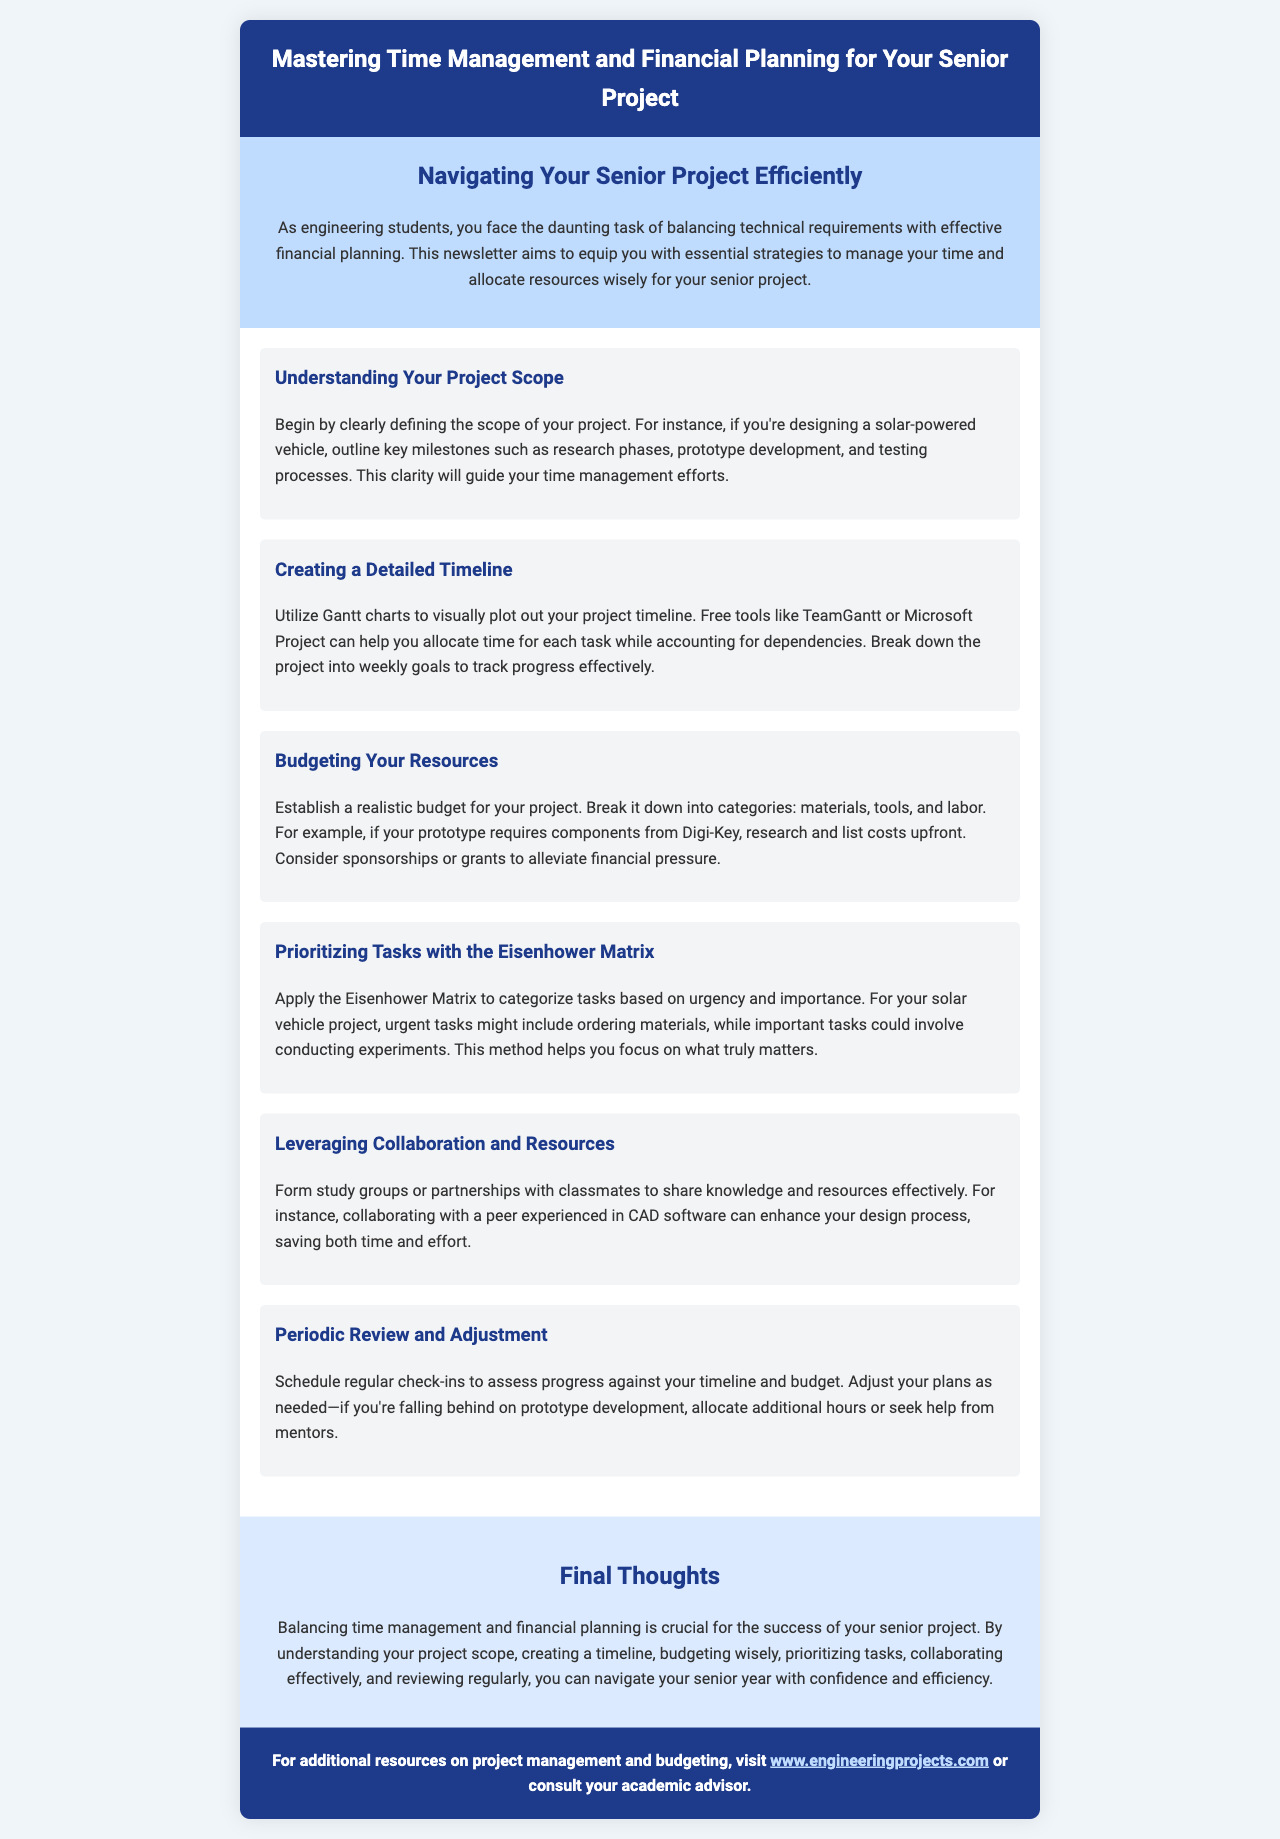What is the title of the newsletter? The title of the newsletter is stated at the top in the header section.
Answer: Mastering Time Management and Financial Planning for Your Senior Project What tool is suggested for creating a detailed project timeline? The newsletter mentions tools that help in plotting project timelines visually, highlighting one specifically.
Answer: Gantt charts What is the first step in understanding your project scope? The document describes the initial action needed when defining a project, which is to clearly establish the project parameters.
Answer: Clearly defining the scope of your project Which budgeting category includes materials, tools, and labor? The newsletter outlines the components of budgeting and specifies these as major categories.
Answer: Budgeting your resources What method does the newsletter suggest for prioritizing tasks? The newsletter introduces a specific matrix-based approach for categorizing project tasks.
Answer: Eisenhower Matrix How often should you schedule reviews for your project? The document mentions the need for periodic assessments regarding timelines and budget allocations.
Answer: Regular check-ins What is a recommended way to alleviate financial pressure? The newsletter provides a strategy to manage finances by seeking external support.
Answer: Sponsorships or grants What is the concluding section of the newsletter called? This title is given to the last part of the newsletter to summarize the main points discussed.
Answer: Final Thoughts 